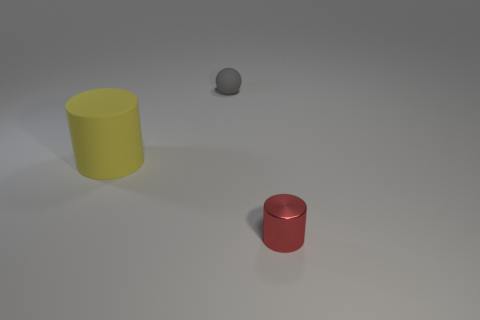What is the shape of the gray matte object that is the same size as the shiny object?
Offer a very short reply. Sphere. There is a object behind the cylinder to the left of the tiny thing that is behind the small red metallic object; what is its color?
Your response must be concise. Gray. Is the red metallic object the same shape as the big thing?
Your response must be concise. Yes. Is the number of yellow things behind the big matte thing the same as the number of metallic cylinders?
Make the answer very short. No. What number of other objects are there of the same material as the sphere?
Provide a succinct answer. 1. There is a cylinder left of the tiny red cylinder; is its size the same as the object that is in front of the large yellow thing?
Provide a succinct answer. No. How many things are small objects that are behind the metal thing or objects that are in front of the sphere?
Your response must be concise. 3. Is there any other thing that is the same shape as the gray thing?
Make the answer very short. No. Does the tiny object behind the red object have the same color as the tiny thing that is in front of the tiny gray thing?
Provide a short and direct response. No. How many metal objects are either red cylinders or yellow cylinders?
Provide a succinct answer. 1. 